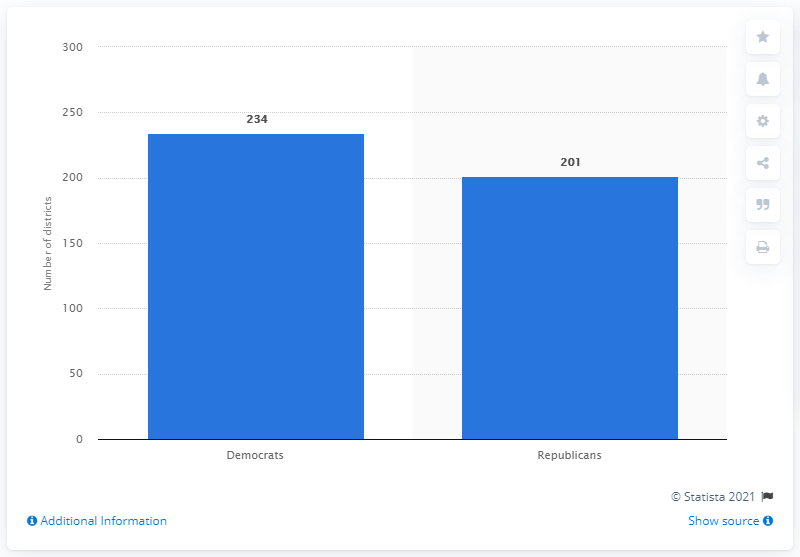Identify some key points in this picture. In the 2018 midterm election, a significant number of Republican seats were won. 